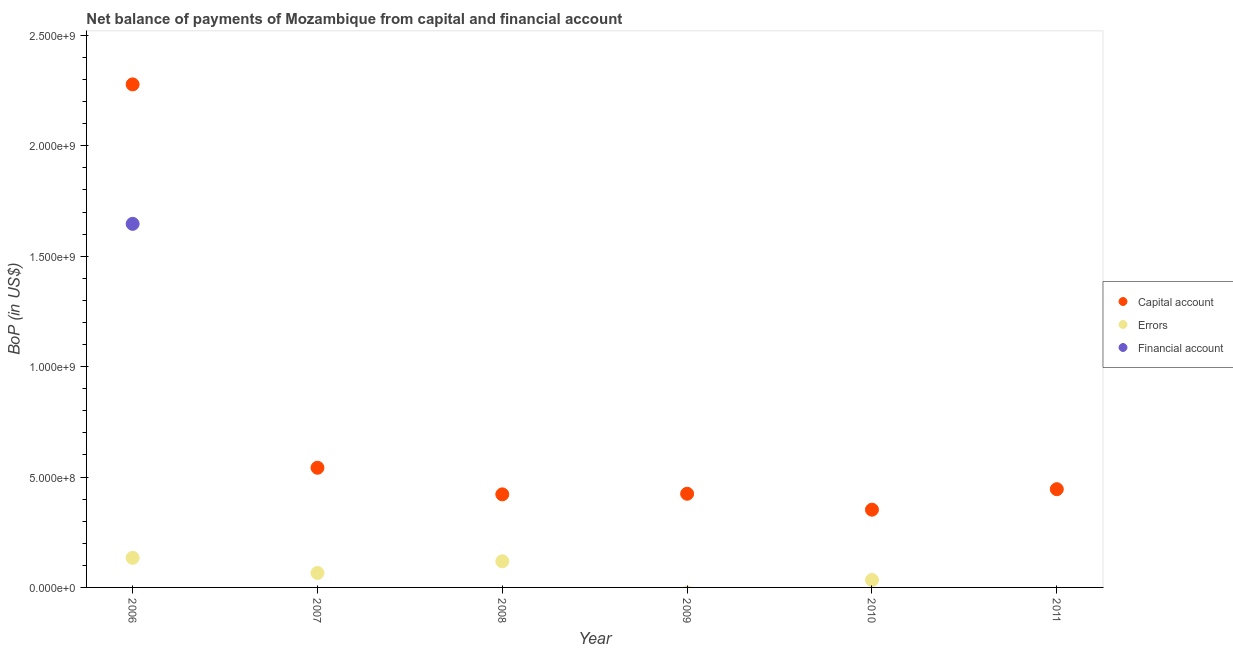How many different coloured dotlines are there?
Ensure brevity in your answer.  3. Is the number of dotlines equal to the number of legend labels?
Offer a very short reply. No. What is the amount of net capital account in 2008?
Make the answer very short. 4.21e+08. Across all years, what is the maximum amount of net capital account?
Your answer should be very brief. 2.28e+09. Across all years, what is the minimum amount of errors?
Your answer should be very brief. 0. What is the total amount of net capital account in the graph?
Make the answer very short. 4.46e+09. What is the difference between the amount of net capital account in 2007 and that in 2011?
Your answer should be compact. 9.71e+07. What is the difference between the amount of net capital account in 2011 and the amount of errors in 2007?
Give a very brief answer. 3.79e+08. What is the average amount of financial account per year?
Your answer should be very brief. 2.74e+08. In the year 2010, what is the difference between the amount of net capital account and amount of errors?
Make the answer very short. 3.19e+08. What is the ratio of the amount of errors in 2006 to that in 2008?
Give a very brief answer. 1.13. Is the amount of net capital account in 2007 less than that in 2009?
Provide a short and direct response. No. Is the difference between the amount of errors in 2007 and 2010 greater than the difference between the amount of net capital account in 2007 and 2010?
Provide a short and direct response. No. What is the difference between the highest and the second highest amount of net capital account?
Offer a terse response. 1.74e+09. What is the difference between the highest and the lowest amount of financial account?
Offer a terse response. 1.65e+09. In how many years, is the amount of financial account greater than the average amount of financial account taken over all years?
Offer a terse response. 1. Is the sum of the amount of net capital account in 2008 and 2010 greater than the maximum amount of errors across all years?
Provide a short and direct response. Yes. Is it the case that in every year, the sum of the amount of net capital account and amount of errors is greater than the amount of financial account?
Provide a succinct answer. Yes. Does the amount of net capital account monotonically increase over the years?
Provide a succinct answer. No. How many dotlines are there?
Offer a very short reply. 3. How many years are there in the graph?
Your answer should be compact. 6. What is the difference between two consecutive major ticks on the Y-axis?
Keep it short and to the point. 5.00e+08. Does the graph contain any zero values?
Your response must be concise. Yes. How many legend labels are there?
Your response must be concise. 3. How are the legend labels stacked?
Make the answer very short. Vertical. What is the title of the graph?
Your answer should be compact. Net balance of payments of Mozambique from capital and financial account. What is the label or title of the Y-axis?
Provide a short and direct response. BoP (in US$). What is the BoP (in US$) of Capital account in 2006?
Your answer should be very brief. 2.28e+09. What is the BoP (in US$) in Errors in 2006?
Your answer should be compact. 1.34e+08. What is the BoP (in US$) in Financial account in 2006?
Offer a terse response. 1.65e+09. What is the BoP (in US$) in Capital account in 2007?
Offer a very short reply. 5.42e+08. What is the BoP (in US$) in Errors in 2007?
Your answer should be compact. 6.55e+07. What is the BoP (in US$) in Financial account in 2007?
Your answer should be compact. 0. What is the BoP (in US$) of Capital account in 2008?
Your response must be concise. 4.21e+08. What is the BoP (in US$) of Errors in 2008?
Your answer should be very brief. 1.18e+08. What is the BoP (in US$) in Capital account in 2009?
Make the answer very short. 4.24e+08. What is the BoP (in US$) of Financial account in 2009?
Your answer should be compact. 0. What is the BoP (in US$) in Capital account in 2010?
Keep it short and to the point. 3.52e+08. What is the BoP (in US$) of Errors in 2010?
Your answer should be very brief. 3.35e+07. What is the BoP (in US$) of Financial account in 2010?
Your answer should be compact. 0. What is the BoP (in US$) of Capital account in 2011?
Provide a short and direct response. 4.45e+08. What is the BoP (in US$) of Errors in 2011?
Give a very brief answer. 0. What is the BoP (in US$) in Financial account in 2011?
Your response must be concise. 0. Across all years, what is the maximum BoP (in US$) of Capital account?
Your answer should be very brief. 2.28e+09. Across all years, what is the maximum BoP (in US$) in Errors?
Your answer should be compact. 1.34e+08. Across all years, what is the maximum BoP (in US$) in Financial account?
Your response must be concise. 1.65e+09. Across all years, what is the minimum BoP (in US$) in Capital account?
Provide a short and direct response. 3.52e+08. What is the total BoP (in US$) in Capital account in the graph?
Make the answer very short. 4.46e+09. What is the total BoP (in US$) in Errors in the graph?
Make the answer very short. 3.51e+08. What is the total BoP (in US$) in Financial account in the graph?
Your answer should be very brief. 1.65e+09. What is the difference between the BoP (in US$) in Capital account in 2006 and that in 2007?
Provide a succinct answer. 1.74e+09. What is the difference between the BoP (in US$) of Errors in 2006 and that in 2007?
Offer a terse response. 6.84e+07. What is the difference between the BoP (in US$) of Capital account in 2006 and that in 2008?
Provide a short and direct response. 1.86e+09. What is the difference between the BoP (in US$) in Errors in 2006 and that in 2008?
Keep it short and to the point. 1.55e+07. What is the difference between the BoP (in US$) in Capital account in 2006 and that in 2009?
Your response must be concise. 1.85e+09. What is the difference between the BoP (in US$) of Capital account in 2006 and that in 2010?
Offer a very short reply. 1.93e+09. What is the difference between the BoP (in US$) of Errors in 2006 and that in 2010?
Your response must be concise. 1.00e+08. What is the difference between the BoP (in US$) of Capital account in 2006 and that in 2011?
Ensure brevity in your answer.  1.83e+09. What is the difference between the BoP (in US$) of Capital account in 2007 and that in 2008?
Give a very brief answer. 1.20e+08. What is the difference between the BoP (in US$) of Errors in 2007 and that in 2008?
Make the answer very short. -5.28e+07. What is the difference between the BoP (in US$) of Capital account in 2007 and that in 2009?
Ensure brevity in your answer.  1.18e+08. What is the difference between the BoP (in US$) of Capital account in 2007 and that in 2010?
Keep it short and to the point. 1.90e+08. What is the difference between the BoP (in US$) of Errors in 2007 and that in 2010?
Your answer should be very brief. 3.20e+07. What is the difference between the BoP (in US$) in Capital account in 2007 and that in 2011?
Provide a succinct answer. 9.71e+07. What is the difference between the BoP (in US$) in Capital account in 2008 and that in 2009?
Your response must be concise. -2.73e+06. What is the difference between the BoP (in US$) of Capital account in 2008 and that in 2010?
Provide a short and direct response. 6.94e+07. What is the difference between the BoP (in US$) in Errors in 2008 and that in 2010?
Your response must be concise. 8.48e+07. What is the difference between the BoP (in US$) of Capital account in 2008 and that in 2011?
Offer a very short reply. -2.33e+07. What is the difference between the BoP (in US$) in Capital account in 2009 and that in 2010?
Give a very brief answer. 7.21e+07. What is the difference between the BoP (in US$) in Capital account in 2009 and that in 2011?
Your answer should be very brief. -2.06e+07. What is the difference between the BoP (in US$) in Capital account in 2010 and that in 2011?
Make the answer very short. -9.28e+07. What is the difference between the BoP (in US$) of Capital account in 2006 and the BoP (in US$) of Errors in 2007?
Give a very brief answer. 2.21e+09. What is the difference between the BoP (in US$) of Capital account in 2006 and the BoP (in US$) of Errors in 2008?
Keep it short and to the point. 2.16e+09. What is the difference between the BoP (in US$) of Capital account in 2006 and the BoP (in US$) of Errors in 2010?
Keep it short and to the point. 2.24e+09. What is the difference between the BoP (in US$) of Capital account in 2007 and the BoP (in US$) of Errors in 2008?
Your answer should be very brief. 4.24e+08. What is the difference between the BoP (in US$) in Capital account in 2007 and the BoP (in US$) in Errors in 2010?
Keep it short and to the point. 5.08e+08. What is the difference between the BoP (in US$) in Capital account in 2008 and the BoP (in US$) in Errors in 2010?
Offer a terse response. 3.88e+08. What is the difference between the BoP (in US$) in Capital account in 2009 and the BoP (in US$) in Errors in 2010?
Offer a terse response. 3.91e+08. What is the average BoP (in US$) in Capital account per year?
Ensure brevity in your answer.  7.44e+08. What is the average BoP (in US$) in Errors per year?
Provide a short and direct response. 5.85e+07. What is the average BoP (in US$) in Financial account per year?
Provide a succinct answer. 2.74e+08. In the year 2006, what is the difference between the BoP (in US$) in Capital account and BoP (in US$) in Errors?
Offer a very short reply. 2.14e+09. In the year 2006, what is the difference between the BoP (in US$) in Capital account and BoP (in US$) in Financial account?
Give a very brief answer. 6.32e+08. In the year 2006, what is the difference between the BoP (in US$) of Errors and BoP (in US$) of Financial account?
Keep it short and to the point. -1.51e+09. In the year 2007, what is the difference between the BoP (in US$) in Capital account and BoP (in US$) in Errors?
Keep it short and to the point. 4.76e+08. In the year 2008, what is the difference between the BoP (in US$) in Capital account and BoP (in US$) in Errors?
Your answer should be compact. 3.03e+08. In the year 2010, what is the difference between the BoP (in US$) of Capital account and BoP (in US$) of Errors?
Offer a very short reply. 3.19e+08. What is the ratio of the BoP (in US$) in Capital account in 2006 to that in 2007?
Make the answer very short. 4.2. What is the ratio of the BoP (in US$) in Errors in 2006 to that in 2007?
Give a very brief answer. 2.04. What is the ratio of the BoP (in US$) in Capital account in 2006 to that in 2008?
Give a very brief answer. 5.4. What is the ratio of the BoP (in US$) of Errors in 2006 to that in 2008?
Ensure brevity in your answer.  1.13. What is the ratio of the BoP (in US$) of Capital account in 2006 to that in 2009?
Offer a terse response. 5.37. What is the ratio of the BoP (in US$) of Capital account in 2006 to that in 2010?
Keep it short and to the point. 6.47. What is the ratio of the BoP (in US$) in Errors in 2006 to that in 2010?
Provide a short and direct response. 3.99. What is the ratio of the BoP (in US$) in Capital account in 2006 to that in 2011?
Keep it short and to the point. 5.12. What is the ratio of the BoP (in US$) of Capital account in 2007 to that in 2008?
Offer a terse response. 1.29. What is the ratio of the BoP (in US$) in Errors in 2007 to that in 2008?
Ensure brevity in your answer.  0.55. What is the ratio of the BoP (in US$) of Capital account in 2007 to that in 2009?
Your response must be concise. 1.28. What is the ratio of the BoP (in US$) of Capital account in 2007 to that in 2010?
Your answer should be very brief. 1.54. What is the ratio of the BoP (in US$) of Errors in 2007 to that in 2010?
Ensure brevity in your answer.  1.95. What is the ratio of the BoP (in US$) in Capital account in 2007 to that in 2011?
Your answer should be very brief. 1.22. What is the ratio of the BoP (in US$) of Capital account in 2008 to that in 2010?
Provide a succinct answer. 1.2. What is the ratio of the BoP (in US$) of Errors in 2008 to that in 2010?
Ensure brevity in your answer.  3.53. What is the ratio of the BoP (in US$) in Capital account in 2008 to that in 2011?
Your answer should be compact. 0.95. What is the ratio of the BoP (in US$) in Capital account in 2009 to that in 2010?
Ensure brevity in your answer.  1.2. What is the ratio of the BoP (in US$) of Capital account in 2009 to that in 2011?
Make the answer very short. 0.95. What is the ratio of the BoP (in US$) of Capital account in 2010 to that in 2011?
Offer a terse response. 0.79. What is the difference between the highest and the second highest BoP (in US$) in Capital account?
Your answer should be very brief. 1.74e+09. What is the difference between the highest and the second highest BoP (in US$) of Errors?
Ensure brevity in your answer.  1.55e+07. What is the difference between the highest and the lowest BoP (in US$) of Capital account?
Offer a very short reply. 1.93e+09. What is the difference between the highest and the lowest BoP (in US$) of Errors?
Ensure brevity in your answer.  1.34e+08. What is the difference between the highest and the lowest BoP (in US$) of Financial account?
Ensure brevity in your answer.  1.65e+09. 